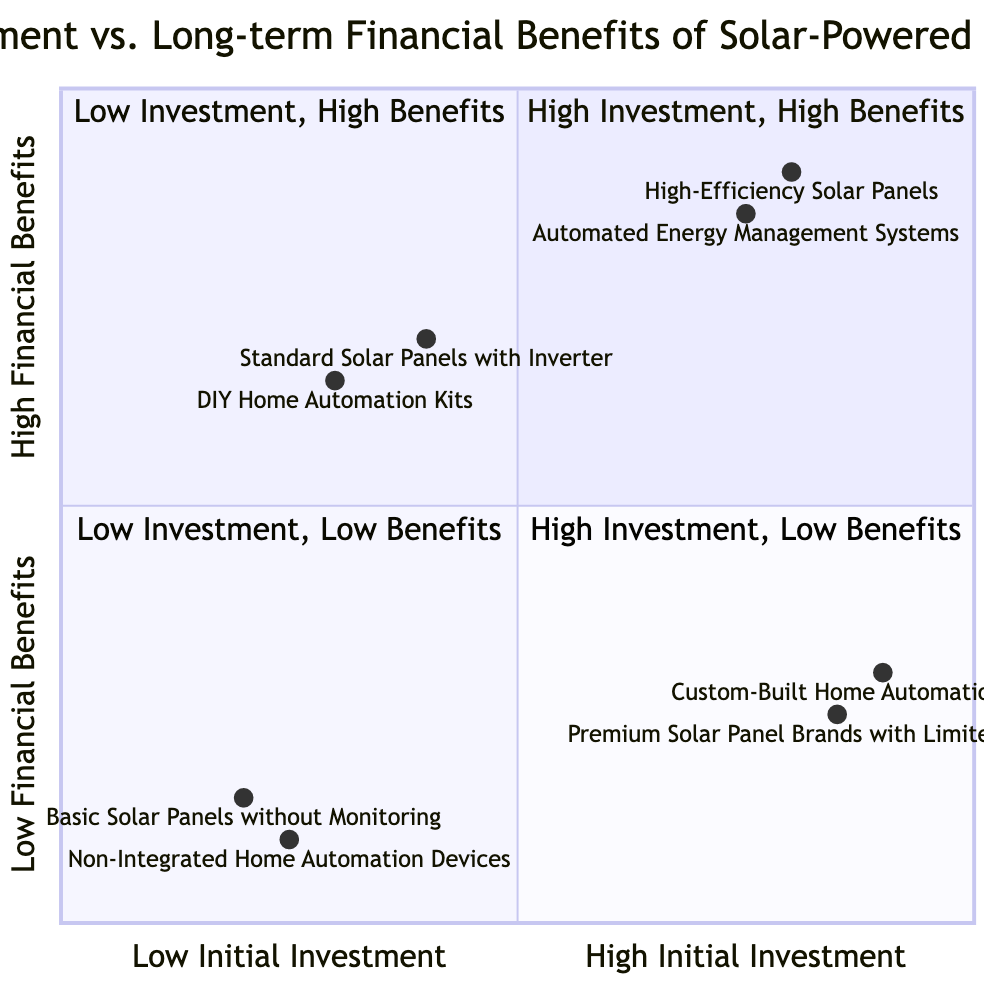What components are in the High Investment, High Benefits quadrant? The High Investment, High Benefits quadrant contains two components: High-Efficiency Solar Panels and Automated Energy Management Systems. These components are explicitly listed under this quadrant in the diagram.
Answer: High-Efficiency Solar Panels, Automated Energy Management Systems How many components are there in the Low Investment, Low Benefits quadrant? The Low Investment, Low Benefits quadrant includes two components: Basic Solar Panels without Monitoring and Non-Integrated Home Automation Devices. Thus, the total number of components is two.
Answer: 2 Which component has the highest initial investment score? Among the components listed, Custom-Built Home Automation Systems have the highest initial investment score of 0.9, indicating that they require the most significant initial investment.
Answer: Custom-Built Home Automation Systems What is the financial benefit score for DIY Home Automation Kits? The financial benefit score for DIY Home Automation Kits is 0.65, as indicated in the diagram for this component categorized in the Low Investment, High Benefits quadrant.
Answer: 0.65 Which quadrant has components with both low initial investment and low financial benefits? The Low Investment, Low Benefits quadrant contains components that meet both criteria of low initial investment and low financial benefits, specifically Basic Solar Panels without Monitoring and Non-Integrated Home Automation Devices.
Answer: Low Investment, Low Benefits quadrant What is the difference in financial benefit scores between High-Efficiency Solar Panels and Premium Solar Panel Brands with Limited Warranty? The financial benefit score for High-Efficiency Solar Panels is 0.9, while the score for Premium Solar Panel Brands with Limited Warranty is 0.25. The difference is 0.9 - 0.25 = 0.65.
Answer: 0.65 Where would you categorize Standard Solar Panels with Inverter on the diagram? Standard Solar Panels with Inverter are categorized in the Low Investment, High Benefits quadrant, as they have a low initial investment score of 0.4 and a high financial benefit score of 0.7 based on their characteristics in the diagram.
Answer: Low Investment, High Benefits quadrant Which component has the lowest financial benefit score? The component with the lowest financial benefit score is Non-Integrated Home Automation Devices, scoring 0.1, as shown in the diagram.
Answer: Non-Integrated Home Automation Devices How does the financial benefit of Automated Energy Management Systems compare with that of Basic Solar Panels without Monitoring? Automated Energy Management Systems have a financial benefit score of 0.85, while Basic Solar Panels without Monitoring have a score of 0.15. The former offers significantly higher financial benefits than the latter.
Answer: Higher for Automated Energy Management Systems 